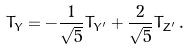<formula> <loc_0><loc_0><loc_500><loc_500>T _ { Y } = - \frac { 1 } { \sqrt { 5 } } T _ { Y ^ { \prime } } + \frac { 2 } { \sqrt { 5 } } T _ { Z ^ { \prime } } \, .</formula> 